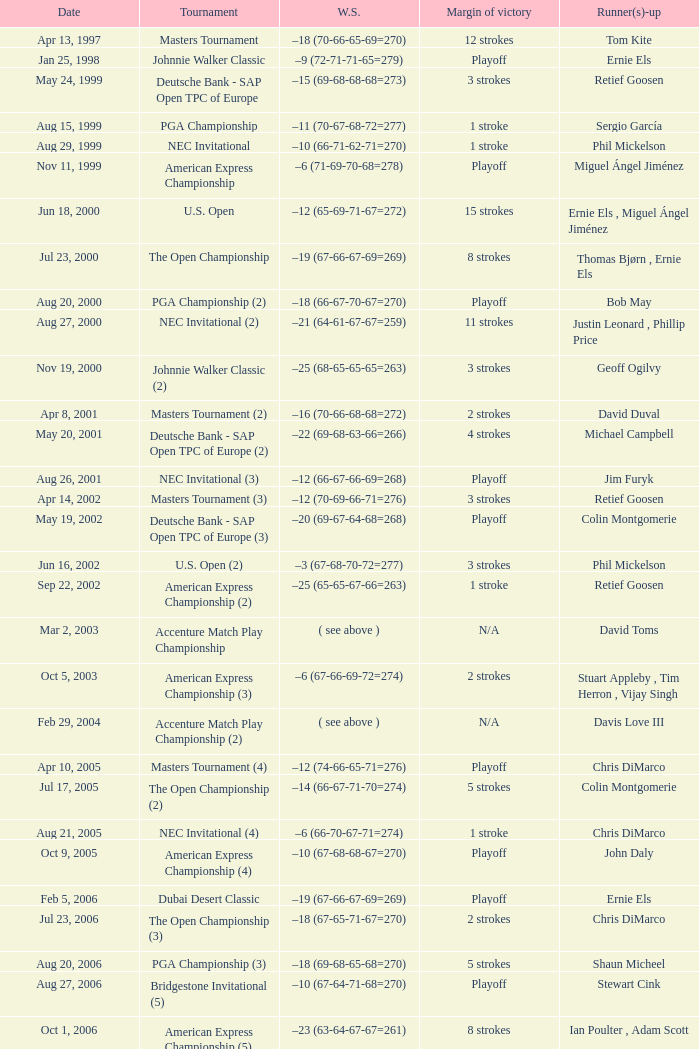Which Tournament has a Margin of victory of 7 strokes Bridgestone Invitational (8). 